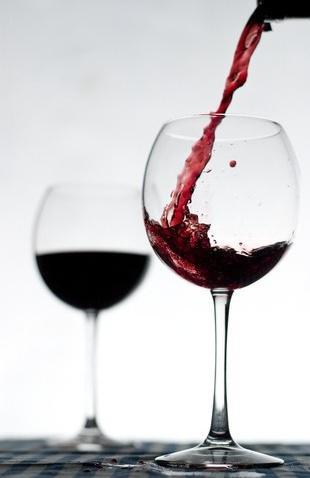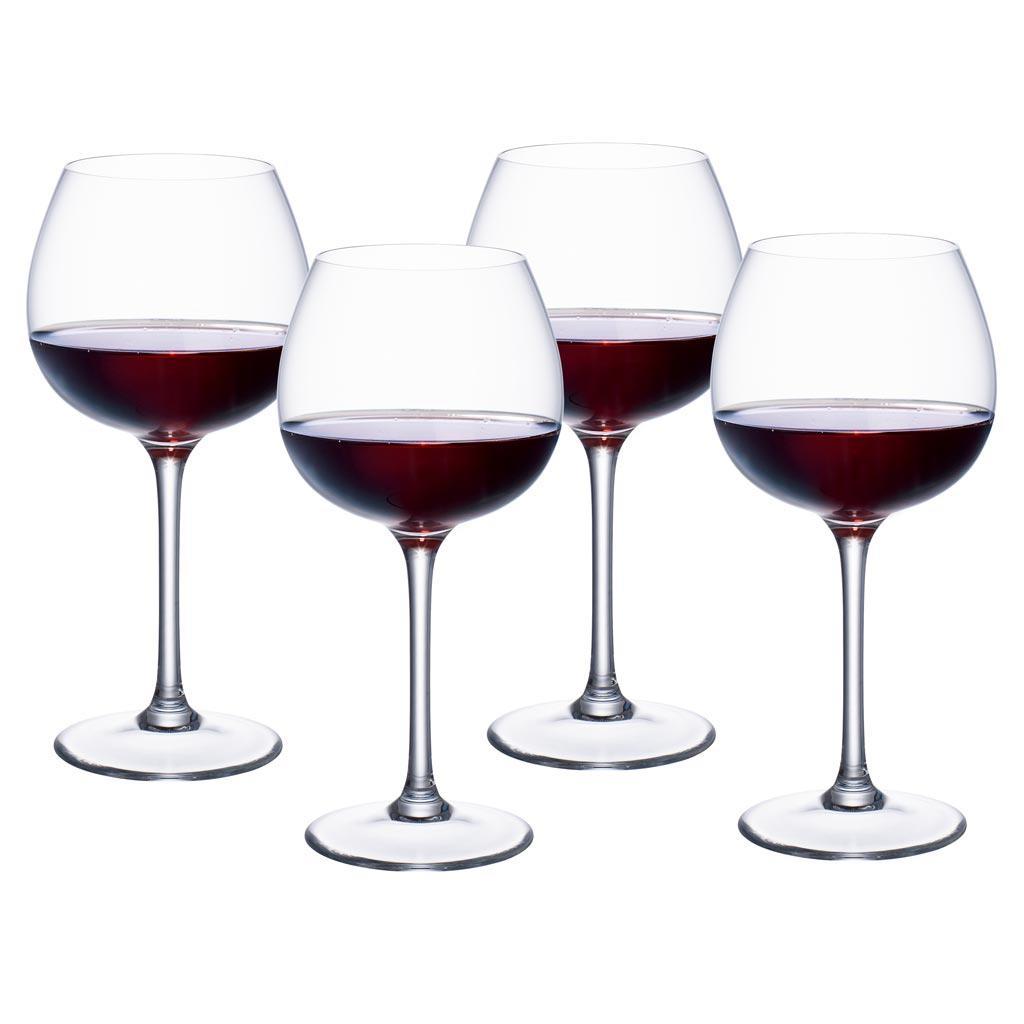The first image is the image on the left, the second image is the image on the right. Given the left and right images, does the statement "At least one of the images shows liquid in a glass that is stationary and not moving." hold true? Answer yes or no. Yes. 